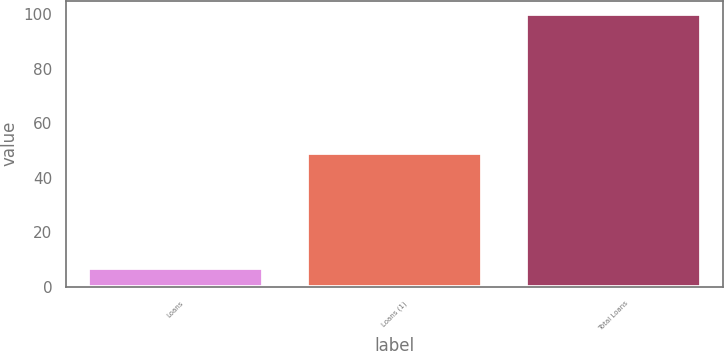<chart> <loc_0><loc_0><loc_500><loc_500><bar_chart><fcel>Loans<fcel>Loans (1)<fcel>Total Loans<nl><fcel>7<fcel>49<fcel>100<nl></chart> 